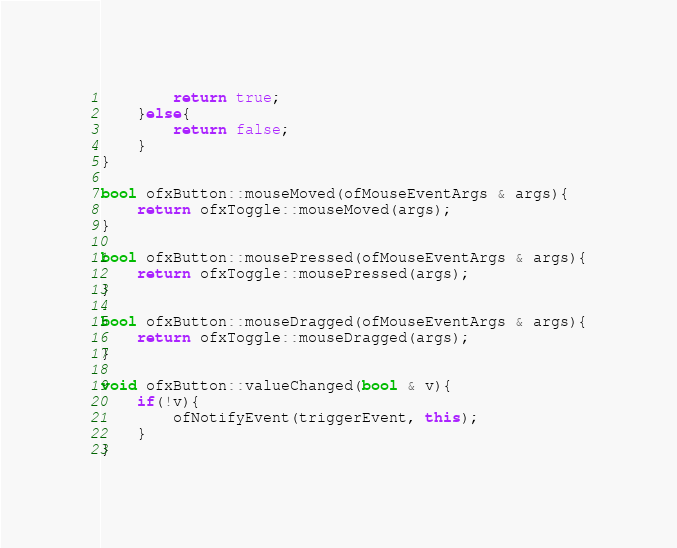<code> <loc_0><loc_0><loc_500><loc_500><_C++_>		return true;
	}else{
		return false;
	}
}

bool ofxButton::mouseMoved(ofMouseEventArgs & args){
	return ofxToggle::mouseMoved(args);
}

bool ofxButton::mousePressed(ofMouseEventArgs & args){
	return ofxToggle::mousePressed(args);
}

bool ofxButton::mouseDragged(ofMouseEventArgs & args){
	return ofxToggle::mouseDragged(args);
}

void ofxButton::valueChanged(bool & v){
	if(!v){
		ofNotifyEvent(triggerEvent, this);
	}
}
</code> 